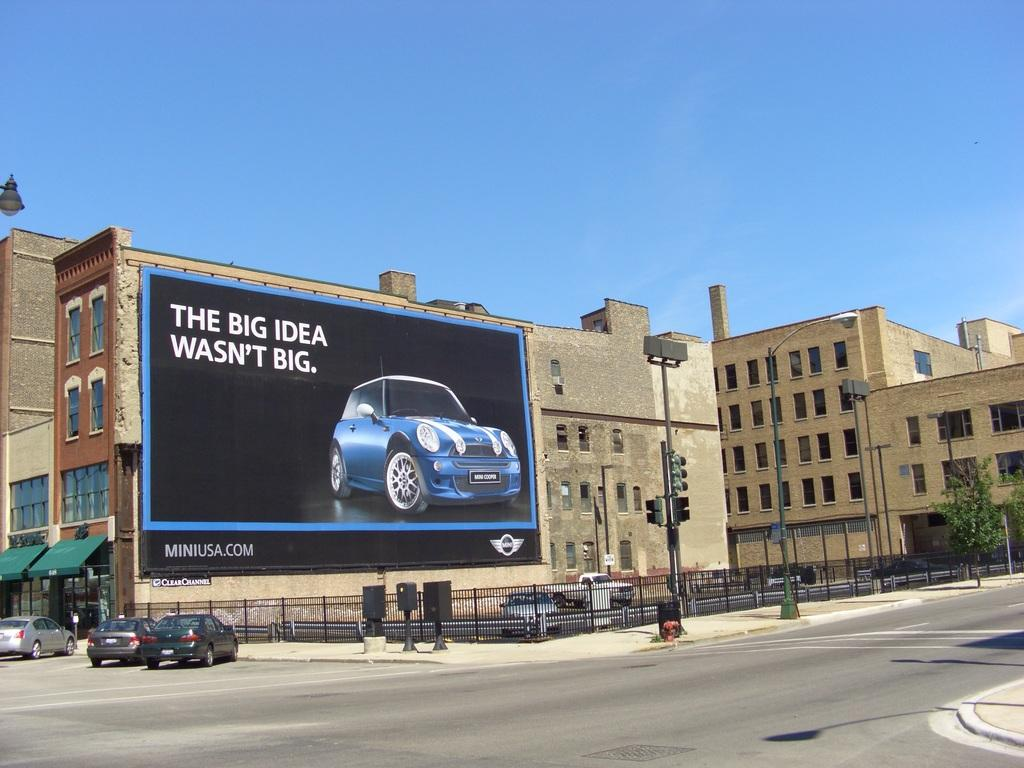Provide a one-sentence caption for the provided image. A large billboard for Mini Cooper hangs in front of a building. 